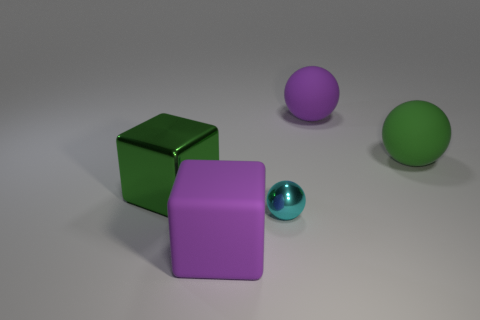How many objects are small blue objects or balls that are right of the large purple ball?
Ensure brevity in your answer.  1. There is a large cube that is behind the matte block; is it the same color as the small shiny ball?
Provide a short and direct response. No. Are there more purple blocks behind the large metallic cube than cyan metallic objects in front of the small cyan object?
Give a very brief answer. No. Are there any other things of the same color as the small metal thing?
Keep it short and to the point. No. How many objects are either big matte balls or large blocks?
Ensure brevity in your answer.  4. There is a purple rubber object behind the green metallic thing; is it the same size as the green cube?
Provide a succinct answer. Yes. What number of other things are there of the same size as the cyan object?
Provide a short and direct response. 0. Is there a purple block?
Provide a succinct answer. Yes. There is a purple thing in front of the purple rubber thing behind the large purple block; what size is it?
Provide a short and direct response. Large. There is a big matte ball in front of the purple matte ball; does it have the same color as the block right of the shiny block?
Provide a succinct answer. No. 